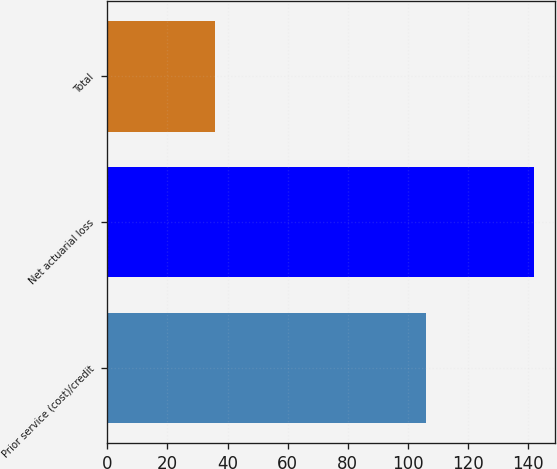Convert chart. <chart><loc_0><loc_0><loc_500><loc_500><bar_chart><fcel>Prior service (cost)/credit<fcel>Net actuarial loss<fcel>Total<nl><fcel>106<fcel>142<fcel>36<nl></chart> 